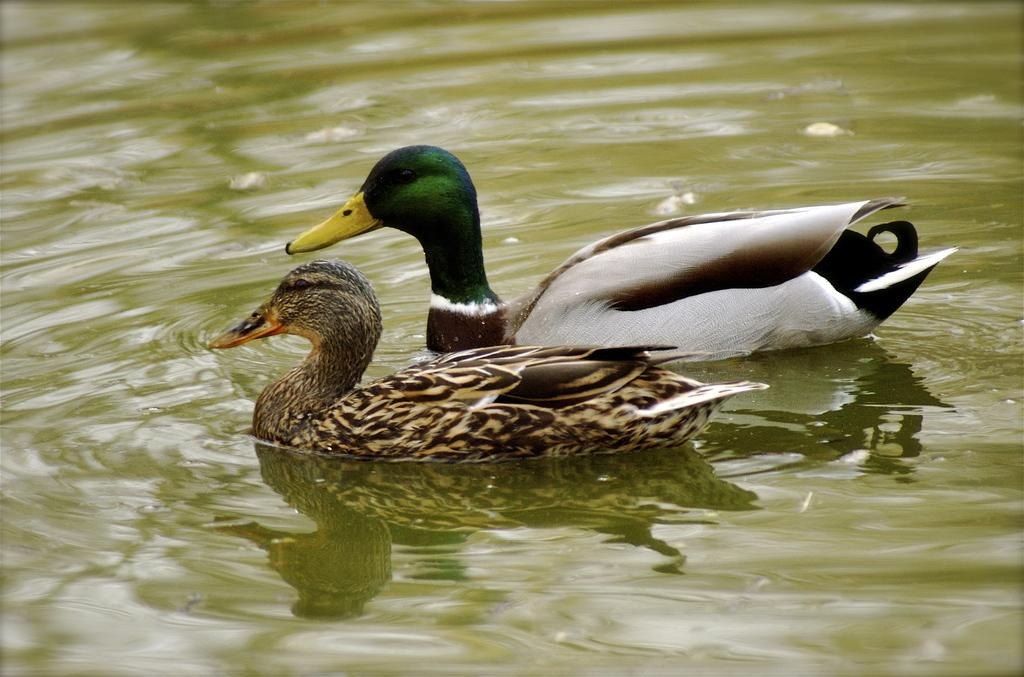What type of animals are in the image? There are ducks in the image. Where are the ducks located? The ducks are in the water. What question is the duck asking in the image? There is no indication in the image that the duck is asking a question. 